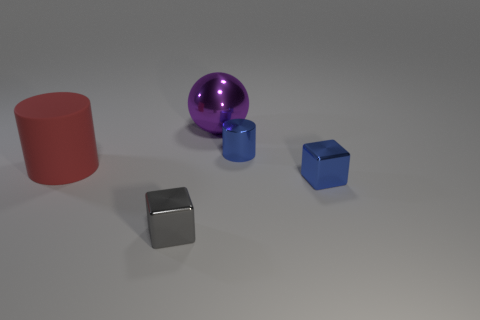There is a cylinder that is in front of the shiny cylinder; is its size the same as the sphere?
Provide a succinct answer. Yes. How many matte things are either blue objects or small blue cubes?
Your response must be concise. 0. The object that is behind the blue block and in front of the tiny blue cylinder is made of what material?
Ensure brevity in your answer.  Rubber. Is the material of the tiny gray thing the same as the purple ball?
Make the answer very short. Yes. There is a object that is both in front of the large red object and on the left side of the purple ball; how big is it?
Offer a very short reply. Small. The small gray object is what shape?
Keep it short and to the point. Cube. How many things are either small purple shiny things or tiny things to the right of the purple metallic object?
Offer a very short reply. 2. There is a tiny metal block on the right side of the gray block; is its color the same as the small cylinder?
Keep it short and to the point. Yes. What is the color of the thing that is both left of the blue metal cube and in front of the red object?
Offer a terse response. Gray. What is the material of the small object that is behind the large red cylinder?
Provide a short and direct response. Metal. 